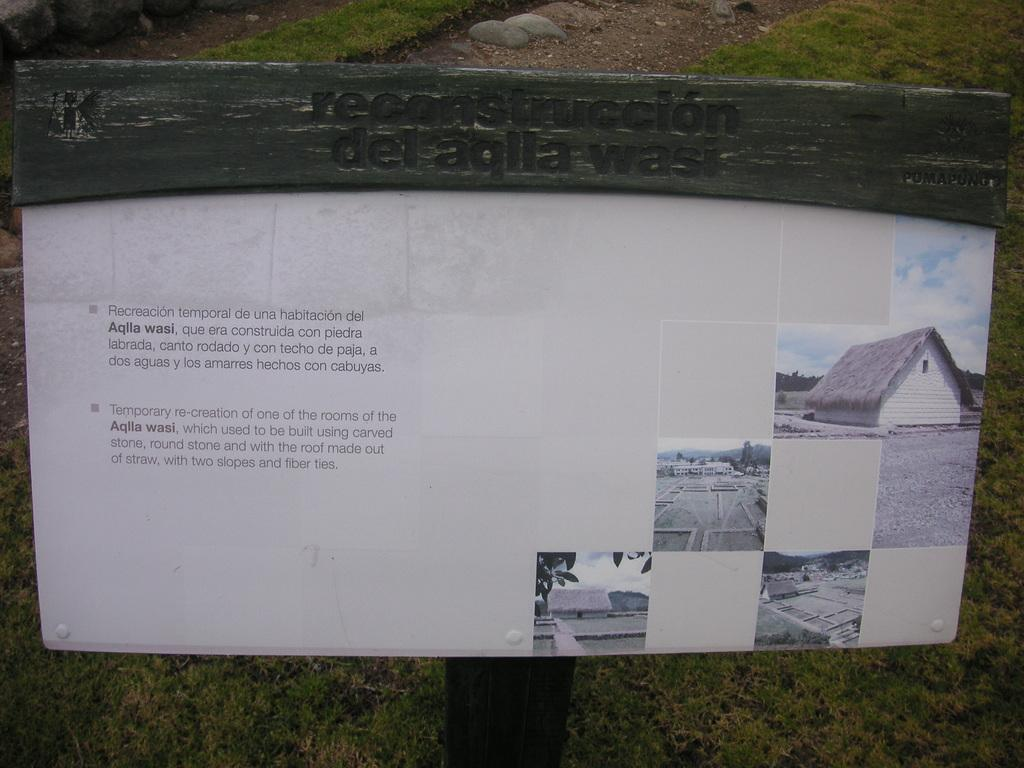What is on the board that is visible in the image? There is text on the board in the image. What type of material is the board made of? The text is on wood in the image. What is the ground surface like in the image? Grass and rocks are visible on the ground in the image. What type of cloth is draped over the stage in the image? There is no stage or cloth present in the image; it features a board with text on wood, grass, and rocks on the ground. 